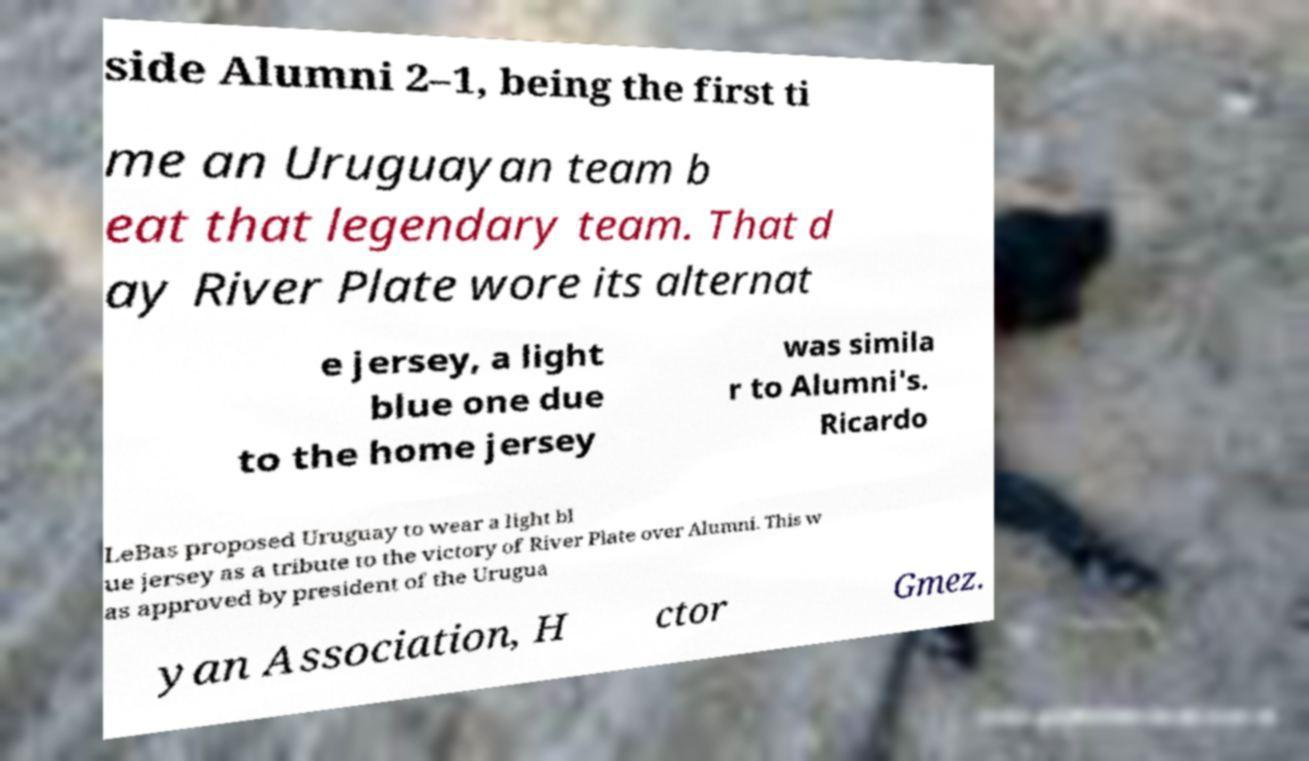There's text embedded in this image that I need extracted. Can you transcribe it verbatim? side Alumni 2–1, being the first ti me an Uruguayan team b eat that legendary team. That d ay River Plate wore its alternat e jersey, a light blue one due to the home jersey was simila r to Alumni's. Ricardo LeBas proposed Uruguay to wear a light bl ue jersey as a tribute to the victory of River Plate over Alumni. This w as approved by president of the Urugua yan Association, H ctor Gmez. 